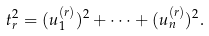Convert formula to latex. <formula><loc_0><loc_0><loc_500><loc_500>t _ { r } ^ { 2 } = ( u ^ { ( r ) } _ { 1 } ) ^ { 2 } + \cdots + ( u ^ { ( r ) } _ { n } ) ^ { 2 } .</formula> 